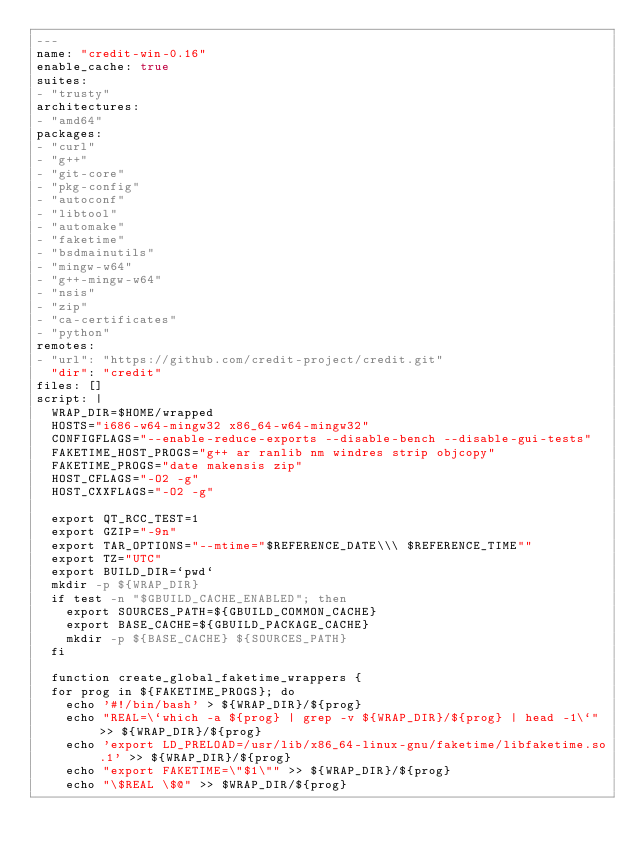Convert code to text. <code><loc_0><loc_0><loc_500><loc_500><_YAML_>---
name: "credit-win-0.16"
enable_cache: true
suites:
- "trusty"
architectures:
- "amd64"
packages:
- "curl"
- "g++"
- "git-core"
- "pkg-config"
- "autoconf"
- "libtool"
- "automake"
- "faketime"
- "bsdmainutils"
- "mingw-w64"
- "g++-mingw-w64"
- "nsis"
- "zip"
- "ca-certificates"
- "python"
remotes:
- "url": "https://github.com/credit-project/credit.git"
  "dir": "credit"
files: []
script: |
  WRAP_DIR=$HOME/wrapped
  HOSTS="i686-w64-mingw32 x86_64-w64-mingw32"
  CONFIGFLAGS="--enable-reduce-exports --disable-bench --disable-gui-tests"
  FAKETIME_HOST_PROGS="g++ ar ranlib nm windres strip objcopy"
  FAKETIME_PROGS="date makensis zip"
  HOST_CFLAGS="-O2 -g"
  HOST_CXXFLAGS="-O2 -g"

  export QT_RCC_TEST=1
  export GZIP="-9n"
  export TAR_OPTIONS="--mtime="$REFERENCE_DATE\\\ $REFERENCE_TIME""
  export TZ="UTC"
  export BUILD_DIR=`pwd`
  mkdir -p ${WRAP_DIR}
  if test -n "$GBUILD_CACHE_ENABLED"; then
    export SOURCES_PATH=${GBUILD_COMMON_CACHE}
    export BASE_CACHE=${GBUILD_PACKAGE_CACHE}
    mkdir -p ${BASE_CACHE} ${SOURCES_PATH}
  fi

  function create_global_faketime_wrappers {
  for prog in ${FAKETIME_PROGS}; do
    echo '#!/bin/bash' > ${WRAP_DIR}/${prog}
    echo "REAL=\`which -a ${prog} | grep -v ${WRAP_DIR}/${prog} | head -1\`" >> ${WRAP_DIR}/${prog}
    echo 'export LD_PRELOAD=/usr/lib/x86_64-linux-gnu/faketime/libfaketime.so.1' >> ${WRAP_DIR}/${prog}
    echo "export FAKETIME=\"$1\"" >> ${WRAP_DIR}/${prog}
    echo "\$REAL \$@" >> $WRAP_DIR/${prog}</code> 